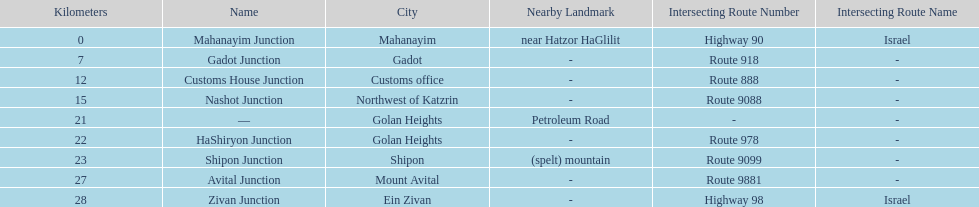What is the total kilometers that separates the mahanayim junction and the shipon junction? 23. 